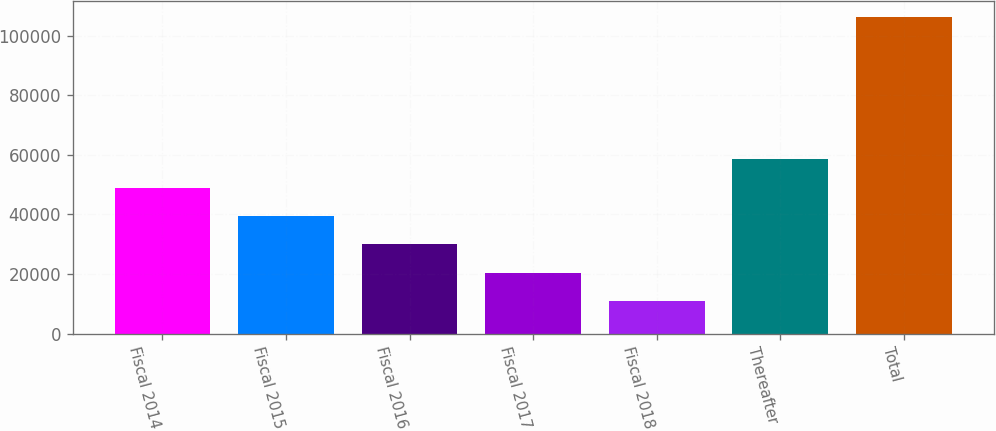<chart> <loc_0><loc_0><loc_500><loc_500><bar_chart><fcel>Fiscal 2014<fcel>Fiscal 2015<fcel>Fiscal 2016<fcel>Fiscal 2017<fcel>Fiscal 2018<fcel>Thereafter<fcel>Total<nl><fcel>49006.8<fcel>39462.6<fcel>29918.4<fcel>20374.2<fcel>10830<fcel>58551<fcel>106272<nl></chart> 